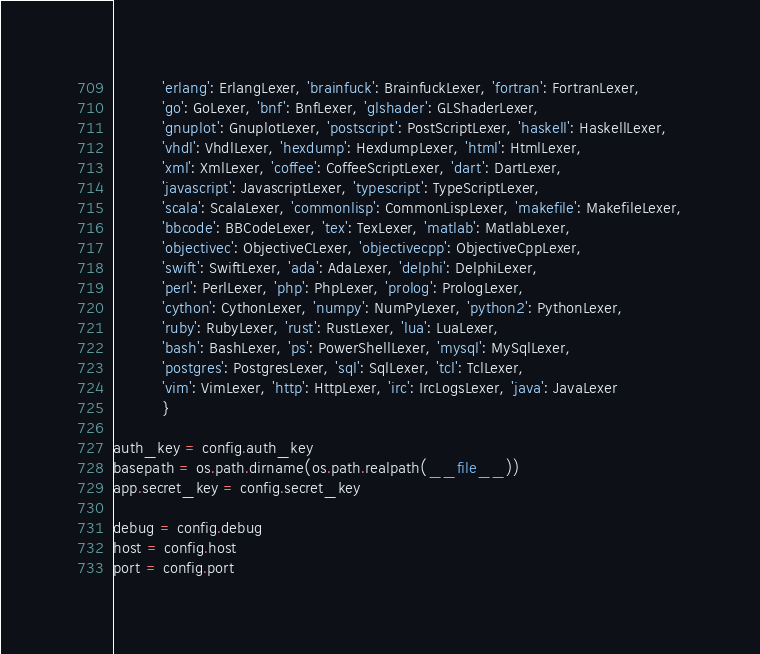Convert code to text. <code><loc_0><loc_0><loc_500><loc_500><_Python_>          'erlang': ErlangLexer, 'brainfuck': BrainfuckLexer, 'fortran': FortranLexer,
          'go': GoLexer, 'bnf': BnfLexer, 'glshader': GLShaderLexer,
          'gnuplot': GnuplotLexer, 'postscript': PostScriptLexer, 'haskell': HaskellLexer,
          'vhdl': VhdlLexer, 'hexdump': HexdumpLexer, 'html': HtmlLexer,
          'xml': XmlLexer, 'coffee': CoffeeScriptLexer, 'dart': DartLexer,
          'javascript': JavascriptLexer, 'typescript': TypeScriptLexer,
          'scala': ScalaLexer, 'commonlisp': CommonLispLexer, 'makefile': MakefileLexer,
          'bbcode': BBCodeLexer, 'tex': TexLexer, 'matlab': MatlabLexer,
          'objectivec': ObjectiveCLexer, 'objectivecpp': ObjectiveCppLexer,
          'swift': SwiftLexer, 'ada': AdaLexer, 'delphi': DelphiLexer,
          'perl': PerlLexer, 'php': PhpLexer, 'prolog': PrologLexer,
          'cython': CythonLexer, 'numpy': NumPyLexer, 'python2': PythonLexer,
          'ruby': RubyLexer, 'rust': RustLexer, 'lua': LuaLexer,
          'bash': BashLexer, 'ps': PowerShellLexer, 'mysql': MySqlLexer,
          'postgres': PostgresLexer, 'sql': SqlLexer, 'tcl': TclLexer,
          'vim': VimLexer, 'http': HttpLexer, 'irc': IrcLogsLexer, 'java': JavaLexer
          }

auth_key = config.auth_key
basepath = os.path.dirname(os.path.realpath(__file__))
app.secret_key = config.secret_key

debug = config.debug
host = config.host
port = config.port
</code> 